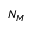<formula> <loc_0><loc_0><loc_500><loc_500>N _ { M }</formula> 